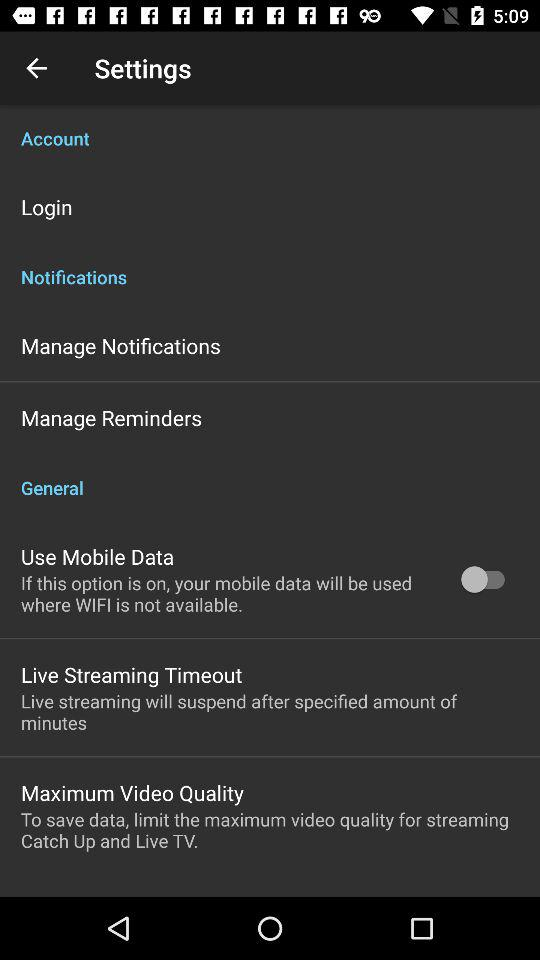Whose account is this?
When the provided information is insufficient, respond with <no answer>. <no answer> 